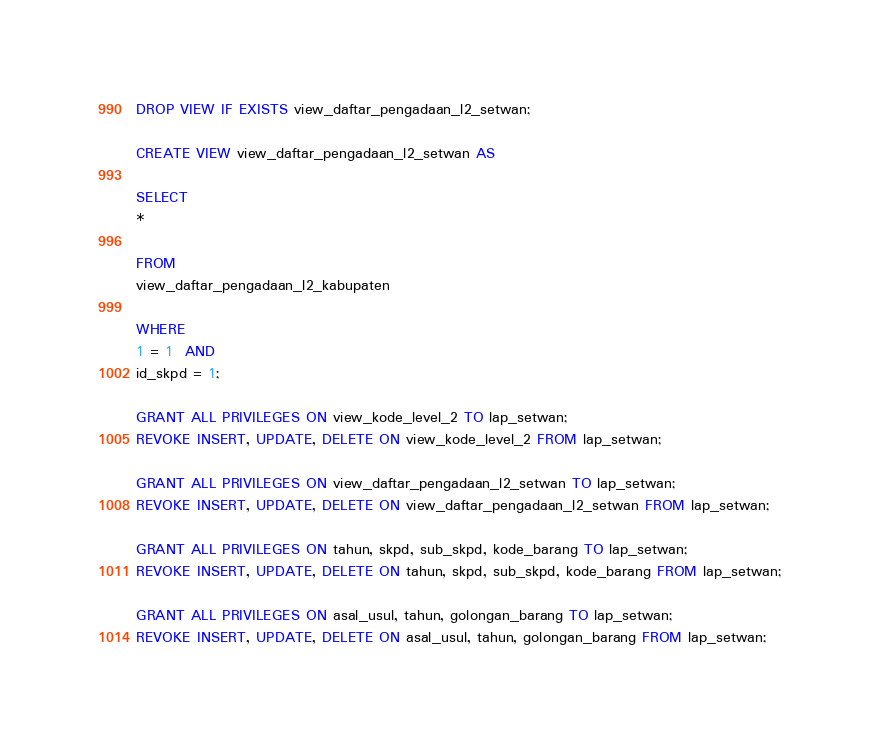Convert code to text. <code><loc_0><loc_0><loc_500><loc_500><_SQL_>DROP VIEW IF EXISTS view_daftar_pengadaan_l2_setwan;

CREATE VIEW view_daftar_pengadaan_l2_setwan AS

SELECT
*

FROM
view_daftar_pengadaan_l2_kabupaten

WHERE
1 = 1  AND
id_skpd = 1;

GRANT ALL PRIVILEGES ON view_kode_level_2 TO lap_setwan;
REVOKE INSERT, UPDATE, DELETE ON view_kode_level_2 FROM lap_setwan;

GRANT ALL PRIVILEGES ON view_daftar_pengadaan_l2_setwan TO lap_setwan;
REVOKE INSERT, UPDATE, DELETE ON view_daftar_pengadaan_l2_setwan FROM lap_setwan;

GRANT ALL PRIVILEGES ON tahun, skpd, sub_skpd, kode_barang TO lap_setwan;
REVOKE INSERT, UPDATE, DELETE ON tahun, skpd, sub_skpd, kode_barang FROM lap_setwan;

GRANT ALL PRIVILEGES ON asal_usul, tahun, golongan_barang TO lap_setwan;
REVOKE INSERT, UPDATE, DELETE ON asal_usul, tahun, golongan_barang FROM lap_setwan;
</code> 